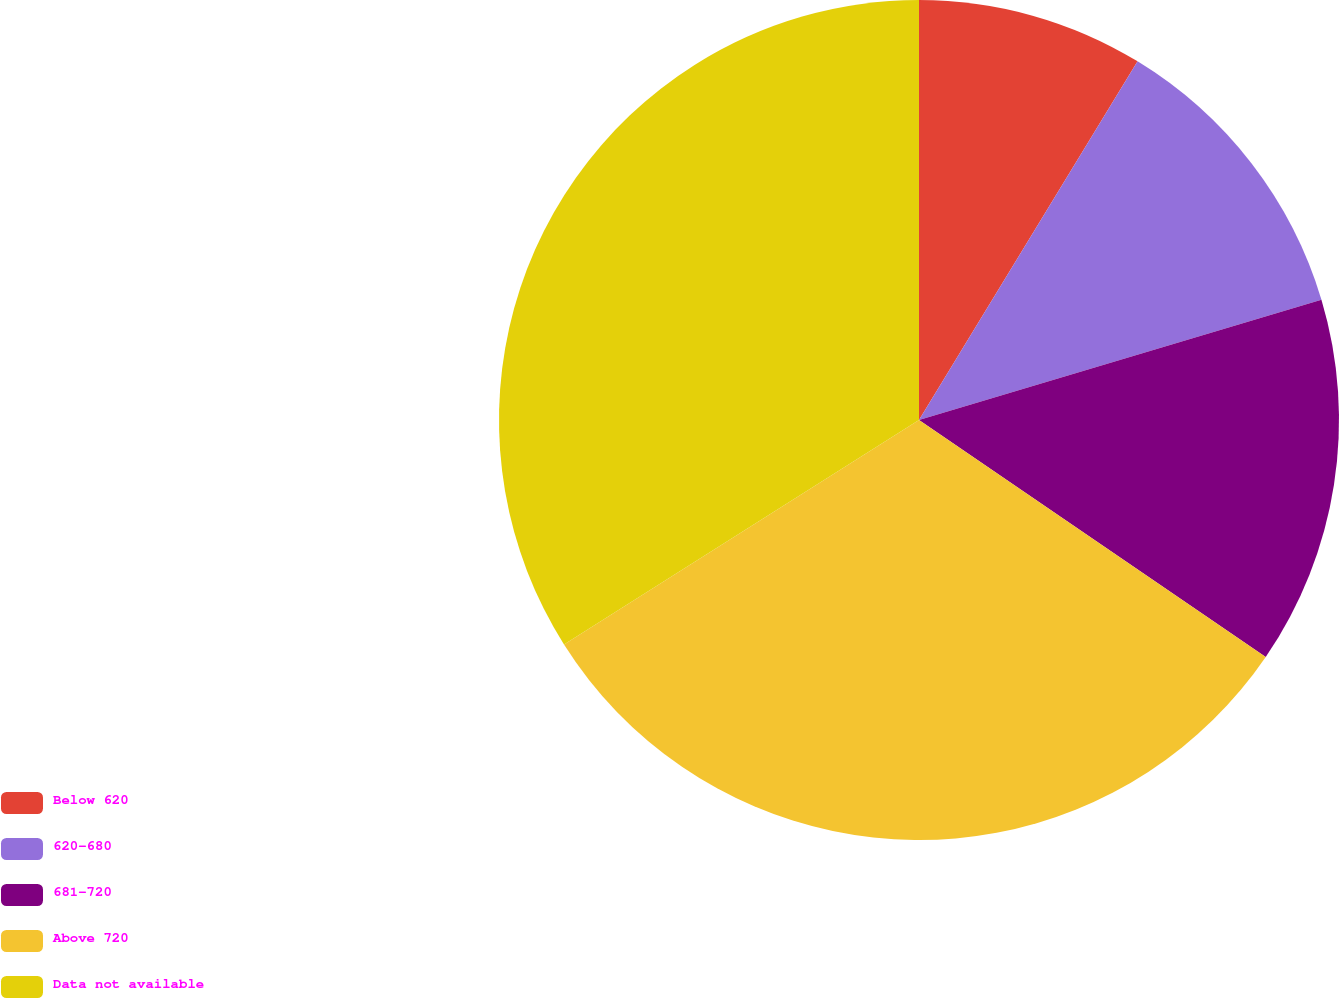<chart> <loc_0><loc_0><loc_500><loc_500><pie_chart><fcel>Below 620<fcel>620-680<fcel>681-720<fcel>Above 720<fcel>Data not available<nl><fcel>8.71%<fcel>11.67%<fcel>14.16%<fcel>31.48%<fcel>33.97%<nl></chart> 